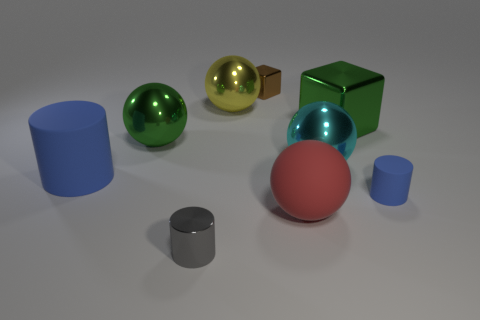Subtract 1 spheres. How many spheres are left? 3 Subtract all blue spheres. Subtract all purple cylinders. How many spheres are left? 4 Add 1 brown objects. How many objects exist? 10 Subtract all balls. How many objects are left? 5 Subtract all yellow spheres. Subtract all big objects. How many objects are left? 2 Add 2 rubber objects. How many rubber objects are left? 5 Add 5 large blue matte objects. How many large blue matte objects exist? 6 Subtract 0 yellow cylinders. How many objects are left? 9 